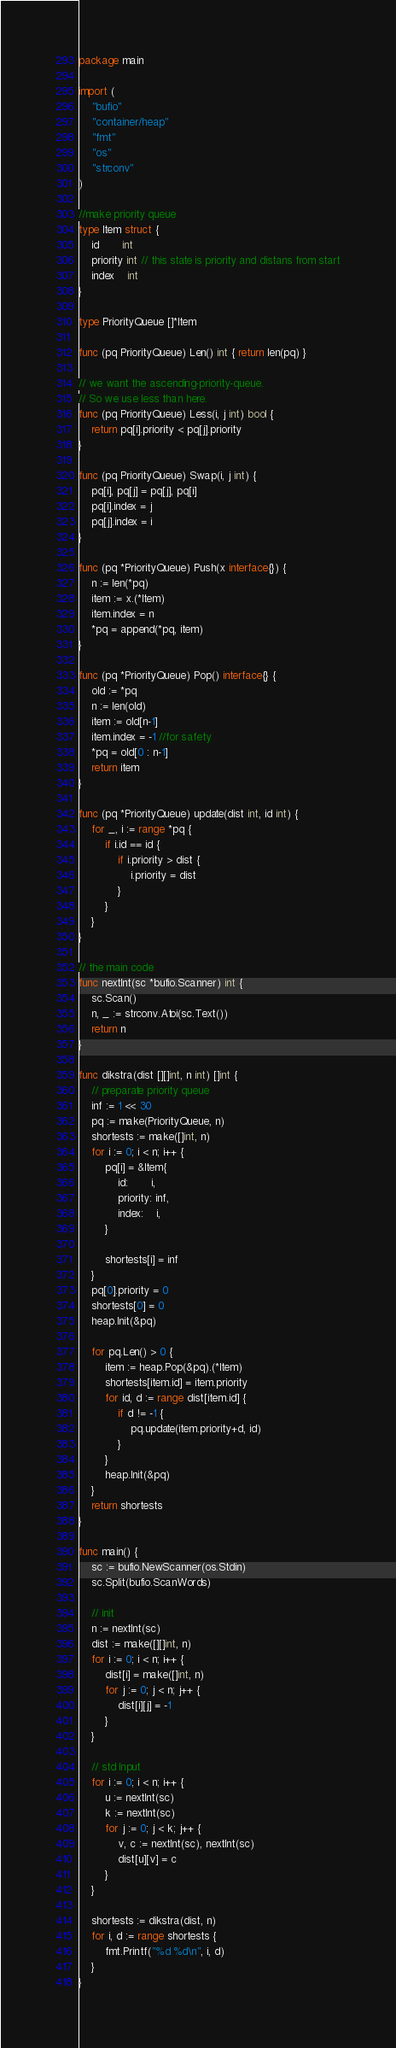Convert code to text. <code><loc_0><loc_0><loc_500><loc_500><_Go_>package main

import (
	"bufio"
	"container/heap"
	"fmt"
	"os"
	"strconv"
)

//make priority queue
type Item struct {
	id       int
	priority int // this state is priority and distans from start
	index    int
}

type PriorityQueue []*Item

func (pq PriorityQueue) Len() int { return len(pq) }

// we want the ascending-priority-queue.
// So we use less than here.
func (pq PriorityQueue) Less(i, j int) bool {
	return pq[i].priority < pq[j].priority
}

func (pq PriorityQueue) Swap(i, j int) {
	pq[i], pq[j] = pq[j], pq[i]
	pq[i].index = j
	pq[j].index = i
}

func (pq *PriorityQueue) Push(x interface{}) {
	n := len(*pq)
	item := x.(*Item)
	item.index = n
	*pq = append(*pq, item)
}

func (pq *PriorityQueue) Pop() interface{} {
	old := *pq
	n := len(old)
	item := old[n-1]
	item.index = -1 //for safety
	*pq = old[0 : n-1]
	return item
}

func (pq *PriorityQueue) update(dist int, id int) {
	for _, i := range *pq {
		if i.id == id {
			if i.priority > dist {
				i.priority = dist
			}
		}
	}
}

// the main code
func nextInt(sc *bufio.Scanner) int {
	sc.Scan()
	n, _ := strconv.Atoi(sc.Text())
	return n
}

func dikstra(dist [][]int, n int) []int {
	// preparate priority queue
	inf := 1 << 30
	pq := make(PriorityQueue, n)
	shortests := make([]int, n)
	for i := 0; i < n; i++ {
		pq[i] = &Item{
			id:       i,
			priority: inf,
			index:    i,
		}

		shortests[i] = inf
	}
	pq[0].priority = 0
	shortests[0] = 0
	heap.Init(&pq)

	for pq.Len() > 0 {
		item := heap.Pop(&pq).(*Item)
		shortests[item.id] = item.priority
		for id, d := range dist[item.id] {
			if d != -1 {
				pq.update(item.priority+d, id)
			}
		}
		heap.Init(&pq)
	}
	return shortests
}

func main() {
	sc := bufio.NewScanner(os.Stdin)
	sc.Split(bufio.ScanWords)

	// init
	n := nextInt(sc)
	dist := make([][]int, n)
	for i := 0; i < n; i++ {
		dist[i] = make([]int, n)
		for j := 0; j < n; j++ {
			dist[i][j] = -1
		}
	}

	// std Input
	for i := 0; i < n; i++ {
		u := nextInt(sc)
		k := nextInt(sc)
		for j := 0; j < k; j++ {
			v, c := nextInt(sc), nextInt(sc)
			dist[u][v] = c
		}
	}

	shortests := dikstra(dist, n)
	for i, d := range shortests {
		fmt.Printf("%d %d\n", i, d)
	}
}

</code> 